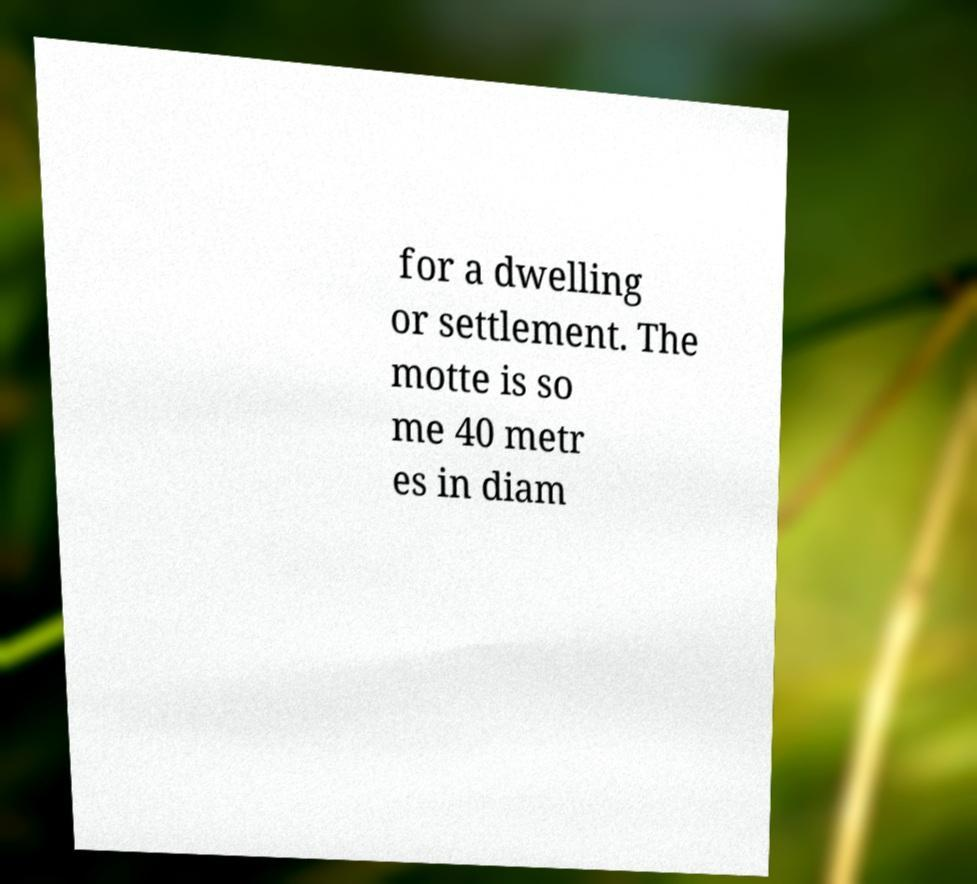For documentation purposes, I need the text within this image transcribed. Could you provide that? for a dwelling or settlement. The motte is so me 40 metr es in diam 